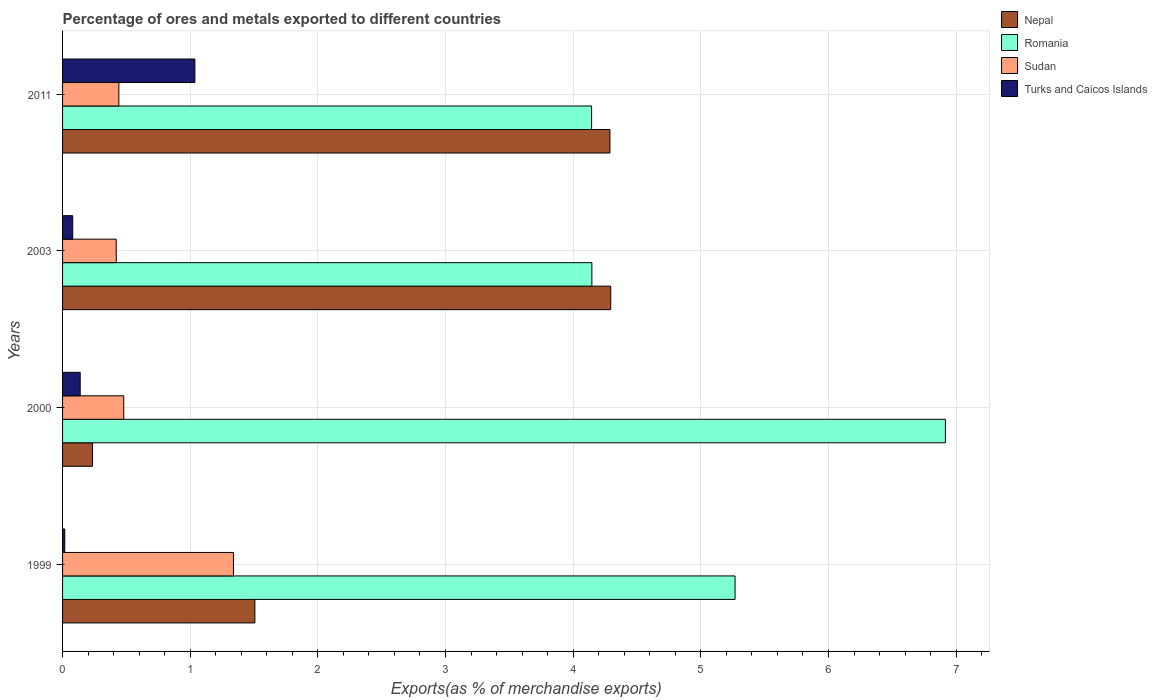How many groups of bars are there?
Make the answer very short. 4. Are the number of bars on each tick of the Y-axis equal?
Offer a very short reply. Yes. How many bars are there on the 2nd tick from the top?
Make the answer very short. 4. How many bars are there on the 2nd tick from the bottom?
Give a very brief answer. 4. What is the label of the 4th group of bars from the top?
Provide a short and direct response. 1999. In how many cases, is the number of bars for a given year not equal to the number of legend labels?
Provide a succinct answer. 0. What is the percentage of exports to different countries in Nepal in 1999?
Provide a short and direct response. 1.51. Across all years, what is the maximum percentage of exports to different countries in Sudan?
Your answer should be very brief. 1.34. Across all years, what is the minimum percentage of exports to different countries in Turks and Caicos Islands?
Ensure brevity in your answer.  0.02. In which year was the percentage of exports to different countries in Sudan maximum?
Keep it short and to the point. 1999. What is the total percentage of exports to different countries in Nepal in the graph?
Make the answer very short. 10.32. What is the difference between the percentage of exports to different countries in Turks and Caicos Islands in 1999 and that in 2011?
Keep it short and to the point. -1.02. What is the difference between the percentage of exports to different countries in Nepal in 2011 and the percentage of exports to different countries in Sudan in 2003?
Make the answer very short. 3.87. What is the average percentage of exports to different countries in Sudan per year?
Your answer should be very brief. 0.67. In the year 2011, what is the difference between the percentage of exports to different countries in Romania and percentage of exports to different countries in Nepal?
Keep it short and to the point. -0.14. What is the ratio of the percentage of exports to different countries in Turks and Caicos Islands in 1999 to that in 2011?
Keep it short and to the point. 0.02. Is the percentage of exports to different countries in Sudan in 1999 less than that in 2003?
Offer a terse response. No. Is the difference between the percentage of exports to different countries in Romania in 1999 and 2000 greater than the difference between the percentage of exports to different countries in Nepal in 1999 and 2000?
Offer a very short reply. No. What is the difference between the highest and the second highest percentage of exports to different countries in Turks and Caicos Islands?
Ensure brevity in your answer.  0.9. What is the difference between the highest and the lowest percentage of exports to different countries in Sudan?
Give a very brief answer. 0.92. Is it the case that in every year, the sum of the percentage of exports to different countries in Nepal and percentage of exports to different countries in Sudan is greater than the sum of percentage of exports to different countries in Turks and Caicos Islands and percentage of exports to different countries in Romania?
Keep it short and to the point. No. What does the 4th bar from the top in 2003 represents?
Offer a very short reply. Nepal. What does the 4th bar from the bottom in 2000 represents?
Keep it short and to the point. Turks and Caicos Islands. Is it the case that in every year, the sum of the percentage of exports to different countries in Nepal and percentage of exports to different countries in Romania is greater than the percentage of exports to different countries in Sudan?
Make the answer very short. Yes. Are all the bars in the graph horizontal?
Offer a terse response. Yes. What is the difference between two consecutive major ticks on the X-axis?
Your answer should be very brief. 1. Are the values on the major ticks of X-axis written in scientific E-notation?
Ensure brevity in your answer.  No. Does the graph contain any zero values?
Your answer should be compact. No. Does the graph contain grids?
Ensure brevity in your answer.  Yes. What is the title of the graph?
Your answer should be very brief. Percentage of ores and metals exported to different countries. What is the label or title of the X-axis?
Offer a terse response. Exports(as % of merchandise exports). What is the Exports(as % of merchandise exports) of Nepal in 1999?
Keep it short and to the point. 1.51. What is the Exports(as % of merchandise exports) in Romania in 1999?
Provide a short and direct response. 5.27. What is the Exports(as % of merchandise exports) in Sudan in 1999?
Give a very brief answer. 1.34. What is the Exports(as % of merchandise exports) in Turks and Caicos Islands in 1999?
Make the answer very short. 0.02. What is the Exports(as % of merchandise exports) in Nepal in 2000?
Give a very brief answer. 0.23. What is the Exports(as % of merchandise exports) in Romania in 2000?
Ensure brevity in your answer.  6.92. What is the Exports(as % of merchandise exports) in Sudan in 2000?
Give a very brief answer. 0.48. What is the Exports(as % of merchandise exports) of Turks and Caicos Islands in 2000?
Keep it short and to the point. 0.14. What is the Exports(as % of merchandise exports) in Nepal in 2003?
Your answer should be compact. 4.29. What is the Exports(as % of merchandise exports) of Romania in 2003?
Offer a very short reply. 4.15. What is the Exports(as % of merchandise exports) in Sudan in 2003?
Provide a short and direct response. 0.42. What is the Exports(as % of merchandise exports) in Turks and Caicos Islands in 2003?
Your response must be concise. 0.08. What is the Exports(as % of merchandise exports) of Nepal in 2011?
Your answer should be compact. 4.29. What is the Exports(as % of merchandise exports) in Romania in 2011?
Provide a succinct answer. 4.14. What is the Exports(as % of merchandise exports) in Sudan in 2011?
Provide a short and direct response. 0.44. What is the Exports(as % of merchandise exports) in Turks and Caicos Islands in 2011?
Offer a very short reply. 1.04. Across all years, what is the maximum Exports(as % of merchandise exports) of Nepal?
Ensure brevity in your answer.  4.29. Across all years, what is the maximum Exports(as % of merchandise exports) of Romania?
Keep it short and to the point. 6.92. Across all years, what is the maximum Exports(as % of merchandise exports) in Sudan?
Offer a very short reply. 1.34. Across all years, what is the maximum Exports(as % of merchandise exports) of Turks and Caicos Islands?
Give a very brief answer. 1.04. Across all years, what is the minimum Exports(as % of merchandise exports) of Nepal?
Offer a terse response. 0.23. Across all years, what is the minimum Exports(as % of merchandise exports) of Romania?
Make the answer very short. 4.14. Across all years, what is the minimum Exports(as % of merchandise exports) of Sudan?
Your answer should be compact. 0.42. Across all years, what is the minimum Exports(as % of merchandise exports) of Turks and Caicos Islands?
Your response must be concise. 0.02. What is the total Exports(as % of merchandise exports) in Nepal in the graph?
Offer a terse response. 10.32. What is the total Exports(as % of merchandise exports) in Romania in the graph?
Ensure brevity in your answer.  20.48. What is the total Exports(as % of merchandise exports) of Sudan in the graph?
Give a very brief answer. 2.68. What is the total Exports(as % of merchandise exports) in Turks and Caicos Islands in the graph?
Your answer should be very brief. 1.27. What is the difference between the Exports(as % of merchandise exports) of Nepal in 1999 and that in 2000?
Offer a terse response. 1.27. What is the difference between the Exports(as % of merchandise exports) of Romania in 1999 and that in 2000?
Offer a very short reply. -1.65. What is the difference between the Exports(as % of merchandise exports) in Sudan in 1999 and that in 2000?
Make the answer very short. 0.86. What is the difference between the Exports(as % of merchandise exports) of Turks and Caicos Islands in 1999 and that in 2000?
Offer a very short reply. -0.12. What is the difference between the Exports(as % of merchandise exports) of Nepal in 1999 and that in 2003?
Your answer should be very brief. -2.79. What is the difference between the Exports(as % of merchandise exports) in Romania in 1999 and that in 2003?
Your answer should be very brief. 1.12. What is the difference between the Exports(as % of merchandise exports) of Sudan in 1999 and that in 2003?
Your response must be concise. 0.92. What is the difference between the Exports(as % of merchandise exports) in Turks and Caicos Islands in 1999 and that in 2003?
Your answer should be compact. -0.06. What is the difference between the Exports(as % of merchandise exports) in Nepal in 1999 and that in 2011?
Your response must be concise. -2.78. What is the difference between the Exports(as % of merchandise exports) of Romania in 1999 and that in 2011?
Provide a succinct answer. 1.12. What is the difference between the Exports(as % of merchandise exports) of Sudan in 1999 and that in 2011?
Make the answer very short. 0.9. What is the difference between the Exports(as % of merchandise exports) of Turks and Caicos Islands in 1999 and that in 2011?
Your response must be concise. -1.02. What is the difference between the Exports(as % of merchandise exports) of Nepal in 2000 and that in 2003?
Your answer should be very brief. -4.06. What is the difference between the Exports(as % of merchandise exports) of Romania in 2000 and that in 2003?
Provide a succinct answer. 2.77. What is the difference between the Exports(as % of merchandise exports) of Sudan in 2000 and that in 2003?
Your answer should be compact. 0.06. What is the difference between the Exports(as % of merchandise exports) in Turks and Caicos Islands in 2000 and that in 2003?
Offer a terse response. 0.06. What is the difference between the Exports(as % of merchandise exports) in Nepal in 2000 and that in 2011?
Provide a short and direct response. -4.05. What is the difference between the Exports(as % of merchandise exports) in Romania in 2000 and that in 2011?
Your answer should be very brief. 2.77. What is the difference between the Exports(as % of merchandise exports) in Sudan in 2000 and that in 2011?
Offer a very short reply. 0.04. What is the difference between the Exports(as % of merchandise exports) of Turks and Caicos Islands in 2000 and that in 2011?
Your answer should be compact. -0.9. What is the difference between the Exports(as % of merchandise exports) of Nepal in 2003 and that in 2011?
Your response must be concise. 0.01. What is the difference between the Exports(as % of merchandise exports) in Romania in 2003 and that in 2011?
Offer a terse response. 0. What is the difference between the Exports(as % of merchandise exports) in Sudan in 2003 and that in 2011?
Your answer should be very brief. -0.02. What is the difference between the Exports(as % of merchandise exports) of Turks and Caicos Islands in 2003 and that in 2011?
Provide a succinct answer. -0.96. What is the difference between the Exports(as % of merchandise exports) in Nepal in 1999 and the Exports(as % of merchandise exports) in Romania in 2000?
Provide a succinct answer. -5.41. What is the difference between the Exports(as % of merchandise exports) of Nepal in 1999 and the Exports(as % of merchandise exports) of Sudan in 2000?
Your answer should be compact. 1.03. What is the difference between the Exports(as % of merchandise exports) in Nepal in 1999 and the Exports(as % of merchandise exports) in Turks and Caicos Islands in 2000?
Keep it short and to the point. 1.37. What is the difference between the Exports(as % of merchandise exports) in Romania in 1999 and the Exports(as % of merchandise exports) in Sudan in 2000?
Give a very brief answer. 4.79. What is the difference between the Exports(as % of merchandise exports) of Romania in 1999 and the Exports(as % of merchandise exports) of Turks and Caicos Islands in 2000?
Offer a very short reply. 5.13. What is the difference between the Exports(as % of merchandise exports) in Sudan in 1999 and the Exports(as % of merchandise exports) in Turks and Caicos Islands in 2000?
Offer a terse response. 1.2. What is the difference between the Exports(as % of merchandise exports) in Nepal in 1999 and the Exports(as % of merchandise exports) in Romania in 2003?
Your response must be concise. -2.64. What is the difference between the Exports(as % of merchandise exports) of Nepal in 1999 and the Exports(as % of merchandise exports) of Sudan in 2003?
Keep it short and to the point. 1.09. What is the difference between the Exports(as % of merchandise exports) in Nepal in 1999 and the Exports(as % of merchandise exports) in Turks and Caicos Islands in 2003?
Your response must be concise. 1.43. What is the difference between the Exports(as % of merchandise exports) of Romania in 1999 and the Exports(as % of merchandise exports) of Sudan in 2003?
Give a very brief answer. 4.85. What is the difference between the Exports(as % of merchandise exports) in Romania in 1999 and the Exports(as % of merchandise exports) in Turks and Caicos Islands in 2003?
Keep it short and to the point. 5.19. What is the difference between the Exports(as % of merchandise exports) in Sudan in 1999 and the Exports(as % of merchandise exports) in Turks and Caicos Islands in 2003?
Your response must be concise. 1.26. What is the difference between the Exports(as % of merchandise exports) of Nepal in 1999 and the Exports(as % of merchandise exports) of Romania in 2011?
Keep it short and to the point. -2.64. What is the difference between the Exports(as % of merchandise exports) in Nepal in 1999 and the Exports(as % of merchandise exports) in Sudan in 2011?
Provide a succinct answer. 1.07. What is the difference between the Exports(as % of merchandise exports) in Nepal in 1999 and the Exports(as % of merchandise exports) in Turks and Caicos Islands in 2011?
Ensure brevity in your answer.  0.47. What is the difference between the Exports(as % of merchandise exports) of Romania in 1999 and the Exports(as % of merchandise exports) of Sudan in 2011?
Your answer should be compact. 4.83. What is the difference between the Exports(as % of merchandise exports) of Romania in 1999 and the Exports(as % of merchandise exports) of Turks and Caicos Islands in 2011?
Ensure brevity in your answer.  4.23. What is the difference between the Exports(as % of merchandise exports) of Sudan in 1999 and the Exports(as % of merchandise exports) of Turks and Caicos Islands in 2011?
Make the answer very short. 0.3. What is the difference between the Exports(as % of merchandise exports) in Nepal in 2000 and the Exports(as % of merchandise exports) in Romania in 2003?
Offer a very short reply. -3.91. What is the difference between the Exports(as % of merchandise exports) in Nepal in 2000 and the Exports(as % of merchandise exports) in Sudan in 2003?
Provide a short and direct response. -0.19. What is the difference between the Exports(as % of merchandise exports) of Nepal in 2000 and the Exports(as % of merchandise exports) of Turks and Caicos Islands in 2003?
Make the answer very short. 0.15. What is the difference between the Exports(as % of merchandise exports) in Romania in 2000 and the Exports(as % of merchandise exports) in Sudan in 2003?
Ensure brevity in your answer.  6.5. What is the difference between the Exports(as % of merchandise exports) in Romania in 2000 and the Exports(as % of merchandise exports) in Turks and Caicos Islands in 2003?
Give a very brief answer. 6.84. What is the difference between the Exports(as % of merchandise exports) in Sudan in 2000 and the Exports(as % of merchandise exports) in Turks and Caicos Islands in 2003?
Provide a succinct answer. 0.4. What is the difference between the Exports(as % of merchandise exports) in Nepal in 2000 and the Exports(as % of merchandise exports) in Romania in 2011?
Offer a very short reply. -3.91. What is the difference between the Exports(as % of merchandise exports) in Nepal in 2000 and the Exports(as % of merchandise exports) in Sudan in 2011?
Offer a terse response. -0.21. What is the difference between the Exports(as % of merchandise exports) in Nepal in 2000 and the Exports(as % of merchandise exports) in Turks and Caicos Islands in 2011?
Your answer should be compact. -0.8. What is the difference between the Exports(as % of merchandise exports) of Romania in 2000 and the Exports(as % of merchandise exports) of Sudan in 2011?
Keep it short and to the point. 6.48. What is the difference between the Exports(as % of merchandise exports) of Romania in 2000 and the Exports(as % of merchandise exports) of Turks and Caicos Islands in 2011?
Ensure brevity in your answer.  5.88. What is the difference between the Exports(as % of merchandise exports) in Sudan in 2000 and the Exports(as % of merchandise exports) in Turks and Caicos Islands in 2011?
Keep it short and to the point. -0.56. What is the difference between the Exports(as % of merchandise exports) of Nepal in 2003 and the Exports(as % of merchandise exports) of Romania in 2011?
Provide a short and direct response. 0.15. What is the difference between the Exports(as % of merchandise exports) of Nepal in 2003 and the Exports(as % of merchandise exports) of Sudan in 2011?
Make the answer very short. 3.85. What is the difference between the Exports(as % of merchandise exports) in Nepal in 2003 and the Exports(as % of merchandise exports) in Turks and Caicos Islands in 2011?
Ensure brevity in your answer.  3.26. What is the difference between the Exports(as % of merchandise exports) in Romania in 2003 and the Exports(as % of merchandise exports) in Sudan in 2011?
Keep it short and to the point. 3.71. What is the difference between the Exports(as % of merchandise exports) of Romania in 2003 and the Exports(as % of merchandise exports) of Turks and Caicos Islands in 2011?
Provide a succinct answer. 3.11. What is the difference between the Exports(as % of merchandise exports) of Sudan in 2003 and the Exports(as % of merchandise exports) of Turks and Caicos Islands in 2011?
Provide a succinct answer. -0.62. What is the average Exports(as % of merchandise exports) in Nepal per year?
Ensure brevity in your answer.  2.58. What is the average Exports(as % of merchandise exports) of Romania per year?
Offer a very short reply. 5.12. What is the average Exports(as % of merchandise exports) in Sudan per year?
Provide a succinct answer. 0.67. What is the average Exports(as % of merchandise exports) in Turks and Caicos Islands per year?
Give a very brief answer. 0.32. In the year 1999, what is the difference between the Exports(as % of merchandise exports) in Nepal and Exports(as % of merchandise exports) in Romania?
Offer a very short reply. -3.76. In the year 1999, what is the difference between the Exports(as % of merchandise exports) of Nepal and Exports(as % of merchandise exports) of Sudan?
Your response must be concise. 0.17. In the year 1999, what is the difference between the Exports(as % of merchandise exports) in Nepal and Exports(as % of merchandise exports) in Turks and Caicos Islands?
Offer a very short reply. 1.49. In the year 1999, what is the difference between the Exports(as % of merchandise exports) in Romania and Exports(as % of merchandise exports) in Sudan?
Ensure brevity in your answer.  3.93. In the year 1999, what is the difference between the Exports(as % of merchandise exports) of Romania and Exports(as % of merchandise exports) of Turks and Caicos Islands?
Your response must be concise. 5.25. In the year 1999, what is the difference between the Exports(as % of merchandise exports) of Sudan and Exports(as % of merchandise exports) of Turks and Caicos Islands?
Provide a succinct answer. 1.32. In the year 2000, what is the difference between the Exports(as % of merchandise exports) of Nepal and Exports(as % of merchandise exports) of Romania?
Ensure brevity in your answer.  -6.68. In the year 2000, what is the difference between the Exports(as % of merchandise exports) in Nepal and Exports(as % of merchandise exports) in Sudan?
Ensure brevity in your answer.  -0.24. In the year 2000, what is the difference between the Exports(as % of merchandise exports) of Nepal and Exports(as % of merchandise exports) of Turks and Caicos Islands?
Offer a terse response. 0.1. In the year 2000, what is the difference between the Exports(as % of merchandise exports) in Romania and Exports(as % of merchandise exports) in Sudan?
Your answer should be very brief. 6.44. In the year 2000, what is the difference between the Exports(as % of merchandise exports) of Romania and Exports(as % of merchandise exports) of Turks and Caicos Islands?
Offer a terse response. 6.78. In the year 2000, what is the difference between the Exports(as % of merchandise exports) in Sudan and Exports(as % of merchandise exports) in Turks and Caicos Islands?
Your answer should be compact. 0.34. In the year 2003, what is the difference between the Exports(as % of merchandise exports) of Nepal and Exports(as % of merchandise exports) of Romania?
Provide a short and direct response. 0.15. In the year 2003, what is the difference between the Exports(as % of merchandise exports) in Nepal and Exports(as % of merchandise exports) in Sudan?
Keep it short and to the point. 3.87. In the year 2003, what is the difference between the Exports(as % of merchandise exports) in Nepal and Exports(as % of merchandise exports) in Turks and Caicos Islands?
Your response must be concise. 4.21. In the year 2003, what is the difference between the Exports(as % of merchandise exports) in Romania and Exports(as % of merchandise exports) in Sudan?
Provide a short and direct response. 3.73. In the year 2003, what is the difference between the Exports(as % of merchandise exports) in Romania and Exports(as % of merchandise exports) in Turks and Caicos Islands?
Your answer should be very brief. 4.07. In the year 2003, what is the difference between the Exports(as % of merchandise exports) of Sudan and Exports(as % of merchandise exports) of Turks and Caicos Islands?
Offer a very short reply. 0.34. In the year 2011, what is the difference between the Exports(as % of merchandise exports) in Nepal and Exports(as % of merchandise exports) in Romania?
Ensure brevity in your answer.  0.14. In the year 2011, what is the difference between the Exports(as % of merchandise exports) of Nepal and Exports(as % of merchandise exports) of Sudan?
Offer a very short reply. 3.85. In the year 2011, what is the difference between the Exports(as % of merchandise exports) in Nepal and Exports(as % of merchandise exports) in Turks and Caicos Islands?
Keep it short and to the point. 3.25. In the year 2011, what is the difference between the Exports(as % of merchandise exports) in Romania and Exports(as % of merchandise exports) in Sudan?
Provide a short and direct response. 3.7. In the year 2011, what is the difference between the Exports(as % of merchandise exports) of Romania and Exports(as % of merchandise exports) of Turks and Caicos Islands?
Offer a terse response. 3.11. In the year 2011, what is the difference between the Exports(as % of merchandise exports) in Sudan and Exports(as % of merchandise exports) in Turks and Caicos Islands?
Your answer should be compact. -0.6. What is the ratio of the Exports(as % of merchandise exports) of Nepal in 1999 to that in 2000?
Your answer should be very brief. 6.42. What is the ratio of the Exports(as % of merchandise exports) of Romania in 1999 to that in 2000?
Provide a succinct answer. 0.76. What is the ratio of the Exports(as % of merchandise exports) in Sudan in 1999 to that in 2000?
Offer a very short reply. 2.79. What is the ratio of the Exports(as % of merchandise exports) of Turks and Caicos Islands in 1999 to that in 2000?
Ensure brevity in your answer.  0.12. What is the ratio of the Exports(as % of merchandise exports) of Nepal in 1999 to that in 2003?
Your answer should be compact. 0.35. What is the ratio of the Exports(as % of merchandise exports) in Romania in 1999 to that in 2003?
Offer a terse response. 1.27. What is the ratio of the Exports(as % of merchandise exports) in Sudan in 1999 to that in 2003?
Make the answer very short. 3.18. What is the ratio of the Exports(as % of merchandise exports) in Turks and Caicos Islands in 1999 to that in 2003?
Ensure brevity in your answer.  0.22. What is the ratio of the Exports(as % of merchandise exports) in Nepal in 1999 to that in 2011?
Offer a very short reply. 0.35. What is the ratio of the Exports(as % of merchandise exports) in Romania in 1999 to that in 2011?
Provide a succinct answer. 1.27. What is the ratio of the Exports(as % of merchandise exports) of Sudan in 1999 to that in 2011?
Offer a terse response. 3.04. What is the ratio of the Exports(as % of merchandise exports) in Turks and Caicos Islands in 1999 to that in 2011?
Your answer should be very brief. 0.02. What is the ratio of the Exports(as % of merchandise exports) of Nepal in 2000 to that in 2003?
Provide a succinct answer. 0.05. What is the ratio of the Exports(as % of merchandise exports) in Romania in 2000 to that in 2003?
Your answer should be very brief. 1.67. What is the ratio of the Exports(as % of merchandise exports) in Sudan in 2000 to that in 2003?
Your answer should be very brief. 1.14. What is the ratio of the Exports(as % of merchandise exports) of Turks and Caicos Islands in 2000 to that in 2003?
Give a very brief answer. 1.73. What is the ratio of the Exports(as % of merchandise exports) in Nepal in 2000 to that in 2011?
Make the answer very short. 0.05. What is the ratio of the Exports(as % of merchandise exports) in Romania in 2000 to that in 2011?
Offer a terse response. 1.67. What is the ratio of the Exports(as % of merchandise exports) in Sudan in 2000 to that in 2011?
Offer a terse response. 1.09. What is the ratio of the Exports(as % of merchandise exports) of Turks and Caicos Islands in 2000 to that in 2011?
Your answer should be compact. 0.13. What is the ratio of the Exports(as % of merchandise exports) in Romania in 2003 to that in 2011?
Your answer should be very brief. 1. What is the ratio of the Exports(as % of merchandise exports) in Sudan in 2003 to that in 2011?
Offer a terse response. 0.95. What is the ratio of the Exports(as % of merchandise exports) of Turks and Caicos Islands in 2003 to that in 2011?
Give a very brief answer. 0.08. What is the difference between the highest and the second highest Exports(as % of merchandise exports) in Nepal?
Offer a terse response. 0.01. What is the difference between the highest and the second highest Exports(as % of merchandise exports) in Romania?
Ensure brevity in your answer.  1.65. What is the difference between the highest and the second highest Exports(as % of merchandise exports) in Sudan?
Provide a succinct answer. 0.86. What is the difference between the highest and the second highest Exports(as % of merchandise exports) in Turks and Caicos Islands?
Ensure brevity in your answer.  0.9. What is the difference between the highest and the lowest Exports(as % of merchandise exports) in Nepal?
Your answer should be very brief. 4.06. What is the difference between the highest and the lowest Exports(as % of merchandise exports) of Romania?
Ensure brevity in your answer.  2.77. What is the difference between the highest and the lowest Exports(as % of merchandise exports) of Sudan?
Provide a short and direct response. 0.92. What is the difference between the highest and the lowest Exports(as % of merchandise exports) in Turks and Caicos Islands?
Offer a very short reply. 1.02. 